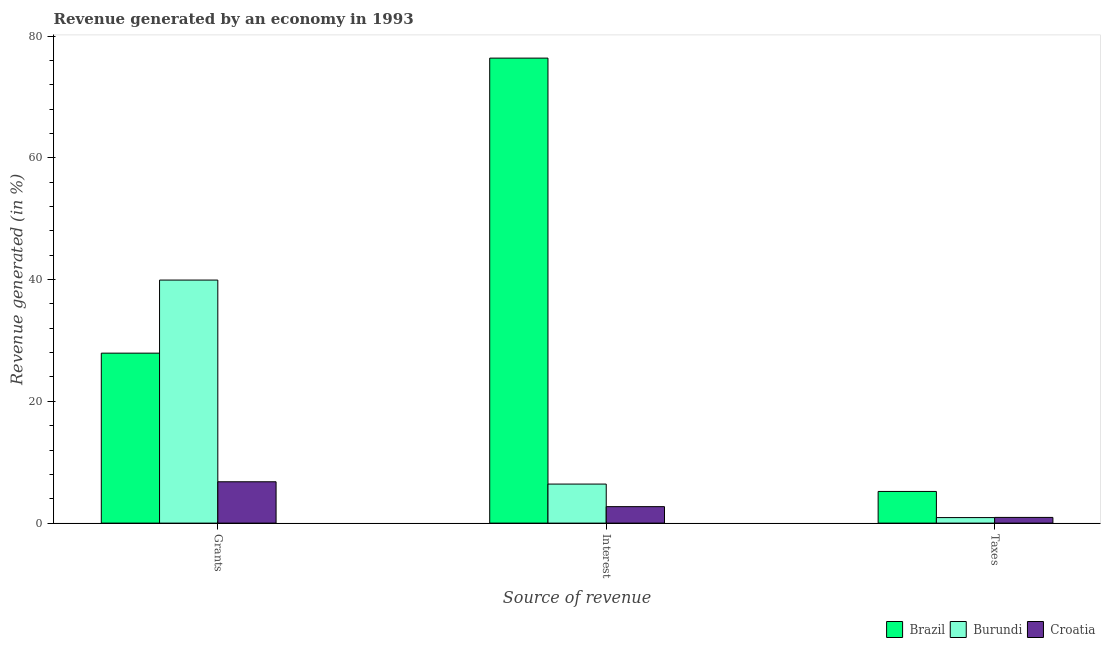What is the label of the 2nd group of bars from the left?
Provide a short and direct response. Interest. What is the percentage of revenue generated by interest in Brazil?
Offer a very short reply. 76.37. Across all countries, what is the maximum percentage of revenue generated by taxes?
Make the answer very short. 5.2. Across all countries, what is the minimum percentage of revenue generated by interest?
Your answer should be very brief. 2.7. In which country was the percentage of revenue generated by grants maximum?
Ensure brevity in your answer.  Burundi. In which country was the percentage of revenue generated by grants minimum?
Offer a very short reply. Croatia. What is the total percentage of revenue generated by taxes in the graph?
Give a very brief answer. 7.05. What is the difference between the percentage of revenue generated by interest in Brazil and that in Croatia?
Make the answer very short. 73.67. What is the difference between the percentage of revenue generated by grants in Brazil and the percentage of revenue generated by interest in Burundi?
Keep it short and to the point. 21.5. What is the average percentage of revenue generated by interest per country?
Ensure brevity in your answer.  28.5. What is the difference between the percentage of revenue generated by grants and percentage of revenue generated by interest in Brazil?
Keep it short and to the point. -48.46. What is the ratio of the percentage of revenue generated by grants in Croatia to that in Burundi?
Give a very brief answer. 0.17. What is the difference between the highest and the second highest percentage of revenue generated by taxes?
Offer a very short reply. 4.27. What is the difference between the highest and the lowest percentage of revenue generated by interest?
Your answer should be very brief. 73.67. What does the 3rd bar from the left in Taxes represents?
Make the answer very short. Croatia. What does the 2nd bar from the right in Grants represents?
Make the answer very short. Burundi. Is it the case that in every country, the sum of the percentage of revenue generated by grants and percentage of revenue generated by interest is greater than the percentage of revenue generated by taxes?
Ensure brevity in your answer.  Yes. How many bars are there?
Give a very brief answer. 9. Does the graph contain any zero values?
Offer a very short reply. No. Where does the legend appear in the graph?
Provide a short and direct response. Bottom right. How are the legend labels stacked?
Provide a succinct answer. Horizontal. What is the title of the graph?
Give a very brief answer. Revenue generated by an economy in 1993. Does "Papua New Guinea" appear as one of the legend labels in the graph?
Keep it short and to the point. No. What is the label or title of the X-axis?
Your answer should be very brief. Source of revenue. What is the label or title of the Y-axis?
Provide a succinct answer. Revenue generated (in %). What is the Revenue generated (in %) in Brazil in Grants?
Your answer should be very brief. 27.92. What is the Revenue generated (in %) of Burundi in Grants?
Give a very brief answer. 39.92. What is the Revenue generated (in %) in Croatia in Grants?
Offer a very short reply. 6.79. What is the Revenue generated (in %) of Brazil in Interest?
Provide a short and direct response. 76.37. What is the Revenue generated (in %) of Burundi in Interest?
Your answer should be compact. 6.41. What is the Revenue generated (in %) of Croatia in Interest?
Your response must be concise. 2.7. What is the Revenue generated (in %) of Brazil in Taxes?
Your answer should be compact. 5.2. What is the Revenue generated (in %) in Burundi in Taxes?
Give a very brief answer. 0.91. What is the Revenue generated (in %) in Croatia in Taxes?
Your response must be concise. 0.94. Across all Source of revenue, what is the maximum Revenue generated (in %) of Brazil?
Provide a succinct answer. 76.37. Across all Source of revenue, what is the maximum Revenue generated (in %) of Burundi?
Offer a terse response. 39.92. Across all Source of revenue, what is the maximum Revenue generated (in %) of Croatia?
Keep it short and to the point. 6.79. Across all Source of revenue, what is the minimum Revenue generated (in %) of Brazil?
Give a very brief answer. 5.2. Across all Source of revenue, what is the minimum Revenue generated (in %) of Burundi?
Ensure brevity in your answer.  0.91. Across all Source of revenue, what is the minimum Revenue generated (in %) in Croatia?
Offer a terse response. 0.94. What is the total Revenue generated (in %) of Brazil in the graph?
Offer a very short reply. 109.49. What is the total Revenue generated (in %) of Burundi in the graph?
Your answer should be very brief. 47.24. What is the total Revenue generated (in %) of Croatia in the graph?
Your answer should be compact. 10.43. What is the difference between the Revenue generated (in %) in Brazil in Grants and that in Interest?
Ensure brevity in your answer.  -48.46. What is the difference between the Revenue generated (in %) of Burundi in Grants and that in Interest?
Offer a terse response. 33.51. What is the difference between the Revenue generated (in %) in Croatia in Grants and that in Interest?
Offer a terse response. 4.08. What is the difference between the Revenue generated (in %) of Brazil in Grants and that in Taxes?
Offer a terse response. 22.72. What is the difference between the Revenue generated (in %) of Burundi in Grants and that in Taxes?
Your answer should be compact. 39.01. What is the difference between the Revenue generated (in %) of Croatia in Grants and that in Taxes?
Ensure brevity in your answer.  5.85. What is the difference between the Revenue generated (in %) in Brazil in Interest and that in Taxes?
Provide a short and direct response. 71.17. What is the difference between the Revenue generated (in %) in Burundi in Interest and that in Taxes?
Your answer should be very brief. 5.51. What is the difference between the Revenue generated (in %) of Croatia in Interest and that in Taxes?
Make the answer very short. 1.77. What is the difference between the Revenue generated (in %) of Brazil in Grants and the Revenue generated (in %) of Burundi in Interest?
Your answer should be compact. 21.5. What is the difference between the Revenue generated (in %) of Brazil in Grants and the Revenue generated (in %) of Croatia in Interest?
Keep it short and to the point. 25.21. What is the difference between the Revenue generated (in %) of Burundi in Grants and the Revenue generated (in %) of Croatia in Interest?
Provide a short and direct response. 37.22. What is the difference between the Revenue generated (in %) of Brazil in Grants and the Revenue generated (in %) of Burundi in Taxes?
Offer a very short reply. 27.01. What is the difference between the Revenue generated (in %) in Brazil in Grants and the Revenue generated (in %) in Croatia in Taxes?
Give a very brief answer. 26.98. What is the difference between the Revenue generated (in %) in Burundi in Grants and the Revenue generated (in %) in Croatia in Taxes?
Ensure brevity in your answer.  38.99. What is the difference between the Revenue generated (in %) of Brazil in Interest and the Revenue generated (in %) of Burundi in Taxes?
Your response must be concise. 75.47. What is the difference between the Revenue generated (in %) of Brazil in Interest and the Revenue generated (in %) of Croatia in Taxes?
Offer a terse response. 75.44. What is the difference between the Revenue generated (in %) of Burundi in Interest and the Revenue generated (in %) of Croatia in Taxes?
Keep it short and to the point. 5.48. What is the average Revenue generated (in %) of Brazil per Source of revenue?
Your response must be concise. 36.5. What is the average Revenue generated (in %) of Burundi per Source of revenue?
Your answer should be compact. 15.75. What is the average Revenue generated (in %) of Croatia per Source of revenue?
Offer a terse response. 3.48. What is the difference between the Revenue generated (in %) in Brazil and Revenue generated (in %) in Burundi in Grants?
Ensure brevity in your answer.  -12. What is the difference between the Revenue generated (in %) of Brazil and Revenue generated (in %) of Croatia in Grants?
Offer a very short reply. 21.13. What is the difference between the Revenue generated (in %) of Burundi and Revenue generated (in %) of Croatia in Grants?
Keep it short and to the point. 33.13. What is the difference between the Revenue generated (in %) of Brazil and Revenue generated (in %) of Burundi in Interest?
Keep it short and to the point. 69.96. What is the difference between the Revenue generated (in %) of Brazil and Revenue generated (in %) of Croatia in Interest?
Your response must be concise. 73.67. What is the difference between the Revenue generated (in %) in Burundi and Revenue generated (in %) in Croatia in Interest?
Your answer should be very brief. 3.71. What is the difference between the Revenue generated (in %) of Brazil and Revenue generated (in %) of Burundi in Taxes?
Give a very brief answer. 4.29. What is the difference between the Revenue generated (in %) of Brazil and Revenue generated (in %) of Croatia in Taxes?
Provide a succinct answer. 4.27. What is the difference between the Revenue generated (in %) in Burundi and Revenue generated (in %) in Croatia in Taxes?
Provide a succinct answer. -0.03. What is the ratio of the Revenue generated (in %) in Brazil in Grants to that in Interest?
Offer a terse response. 0.37. What is the ratio of the Revenue generated (in %) in Burundi in Grants to that in Interest?
Offer a very short reply. 6.22. What is the ratio of the Revenue generated (in %) in Croatia in Grants to that in Interest?
Offer a very short reply. 2.51. What is the ratio of the Revenue generated (in %) of Brazil in Grants to that in Taxes?
Your answer should be compact. 5.37. What is the ratio of the Revenue generated (in %) in Burundi in Grants to that in Taxes?
Offer a very short reply. 43.96. What is the ratio of the Revenue generated (in %) of Croatia in Grants to that in Taxes?
Offer a terse response. 7.26. What is the ratio of the Revenue generated (in %) of Brazil in Interest to that in Taxes?
Give a very brief answer. 14.68. What is the ratio of the Revenue generated (in %) in Burundi in Interest to that in Taxes?
Offer a terse response. 7.06. What is the ratio of the Revenue generated (in %) in Croatia in Interest to that in Taxes?
Your answer should be very brief. 2.89. What is the difference between the highest and the second highest Revenue generated (in %) of Brazil?
Provide a succinct answer. 48.46. What is the difference between the highest and the second highest Revenue generated (in %) of Burundi?
Offer a terse response. 33.51. What is the difference between the highest and the second highest Revenue generated (in %) in Croatia?
Keep it short and to the point. 4.08. What is the difference between the highest and the lowest Revenue generated (in %) of Brazil?
Offer a terse response. 71.17. What is the difference between the highest and the lowest Revenue generated (in %) of Burundi?
Your answer should be very brief. 39.01. What is the difference between the highest and the lowest Revenue generated (in %) of Croatia?
Give a very brief answer. 5.85. 